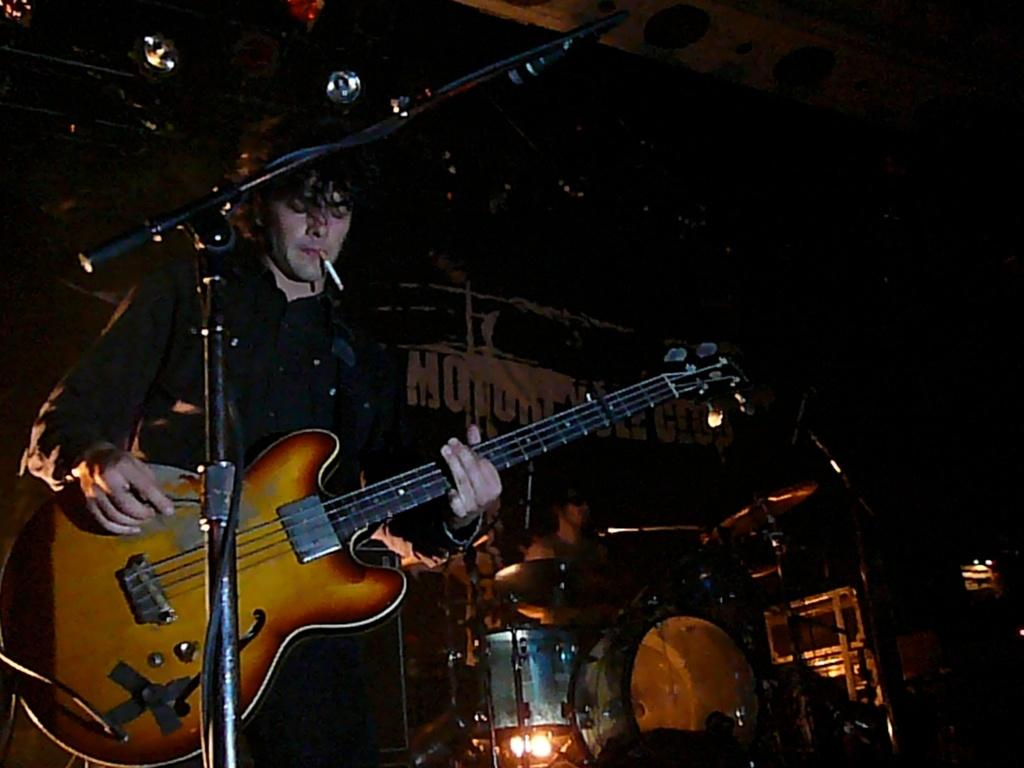What are the persons in the image doing? The persons in the image are playing musical instruments. Which specific musical instrument is being played in the image? A guitar is being played in the image. What other musical instrument is being played in the image? Drums are being played in the image. What can be seen on the table in the image? There are other musical instruments on the table. How would you describe the lighting in the image? The background of the image is dark. What type of unit can be seen being measured with a brass ruler in the image? There is no unit or brass ruler present in the image; it features persons playing musical instruments. Can you tell me how many scissors are being used to play the drums in the image? There are no scissors present in the image, and they are not being used to play the drums. 